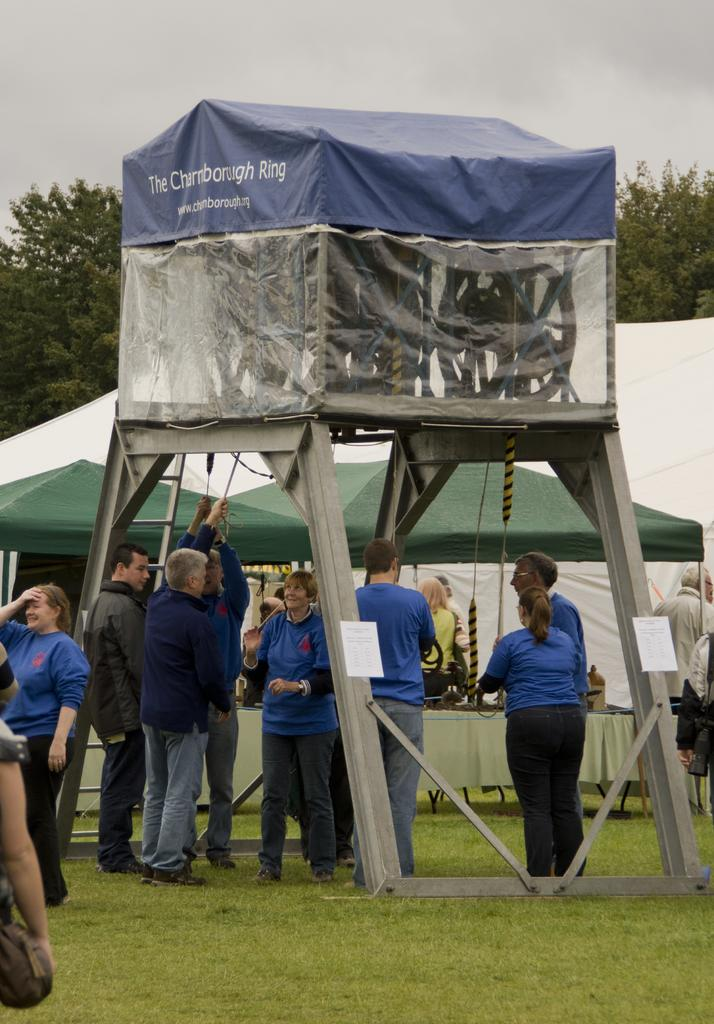What can be seen in the image? There are people standing in the image. What structures are present in the image? There are tents in the image. What type of natural environment is visible in the image? There are trees in the image. Is the sidewalk visible in the image? There is no sidewalk present in the image. Can you tell me the temperature of the uncle in the image? There is no uncle mentioned in the image, and temperature cannot be determined from a visual representation. 